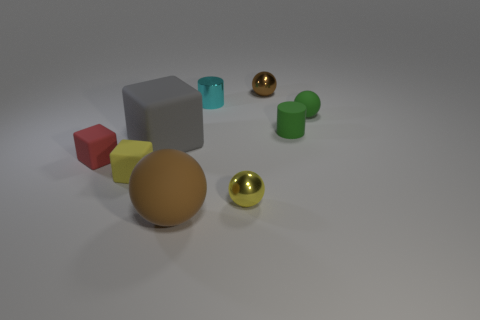There is a green ball; is its size the same as the cube behind the red thing?
Provide a short and direct response. No. What number of tiny purple blocks are there?
Offer a terse response. 0. What number of brown things are either large balls or tiny cylinders?
Give a very brief answer. 1. Is the material of the tiny green thing that is on the right side of the tiny green cylinder the same as the red object?
Offer a terse response. Yes. What number of other things are there of the same material as the green cylinder
Provide a succinct answer. 5. What material is the tiny cyan cylinder?
Your response must be concise. Metal. There is a metallic ball that is behind the big gray matte thing; what size is it?
Give a very brief answer. Small. There is a tiny yellow matte thing that is in front of the small rubber sphere; how many tiny cyan objects are to the right of it?
Keep it short and to the point. 1. Is the shape of the tiny yellow thing that is left of the tiny yellow metal thing the same as the large thing that is in front of the tiny red matte object?
Your response must be concise. No. How many small things are both behind the red block and in front of the tiny brown object?
Offer a very short reply. 3. 